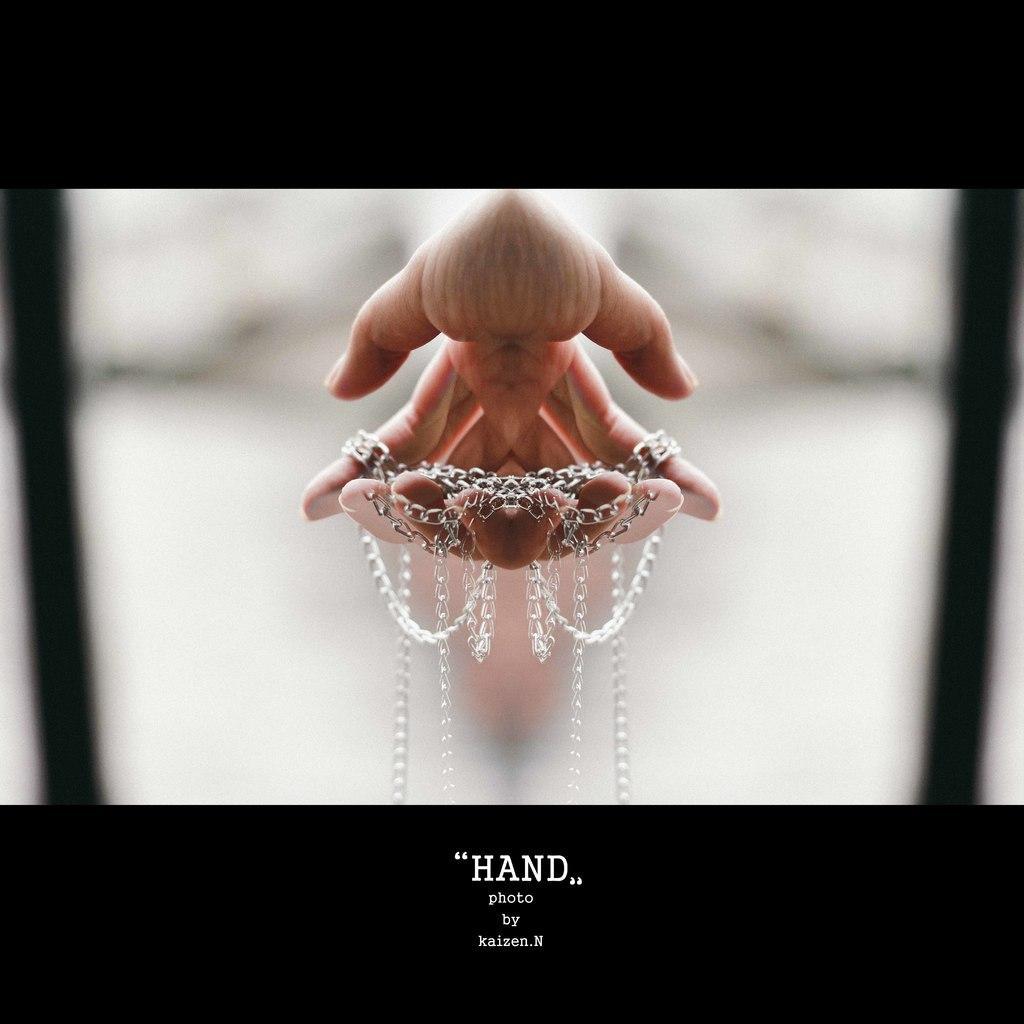Can you describe this image briefly? This image consists of a photograph. In which there are hands along with the chain. It looks like it is edited. At the bottom, there is a text. 